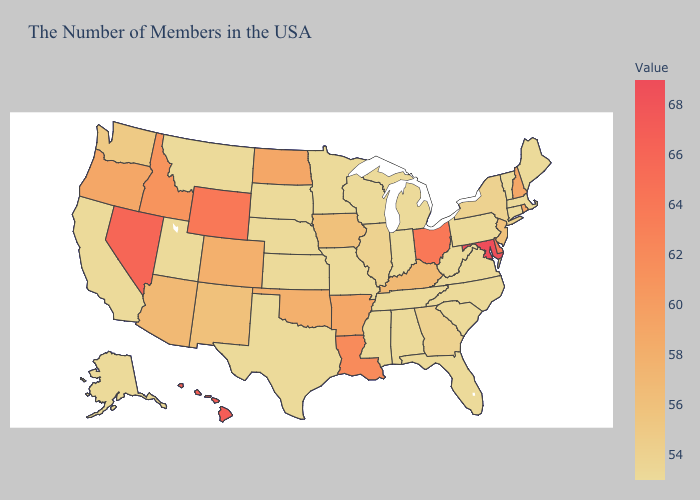Which states hav the highest value in the Northeast?
Answer briefly. Rhode Island, New Hampshire. Does Alaska have the highest value in the West?
Answer briefly. No. Does Indiana have the lowest value in the USA?
Concise answer only. Yes. Which states have the lowest value in the USA?
Write a very short answer. Maine, Massachusetts, Vermont, Connecticut, Pennsylvania, Virginia, North Carolina, South Carolina, West Virginia, Florida, Michigan, Indiana, Alabama, Tennessee, Wisconsin, Mississippi, Missouri, Minnesota, Kansas, Nebraska, Texas, South Dakota, Utah, Montana, California, Alaska. Does Kansas have the lowest value in the MidWest?
Write a very short answer. Yes. Among the states that border Delaware , which have the lowest value?
Quick response, please. Pennsylvania. Does Tennessee have the lowest value in the South?
Quick response, please. Yes. 